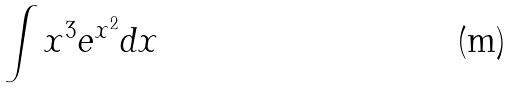<formula> <loc_0><loc_0><loc_500><loc_500>\int x ^ { 3 } e ^ { x ^ { 2 } } d x</formula> 